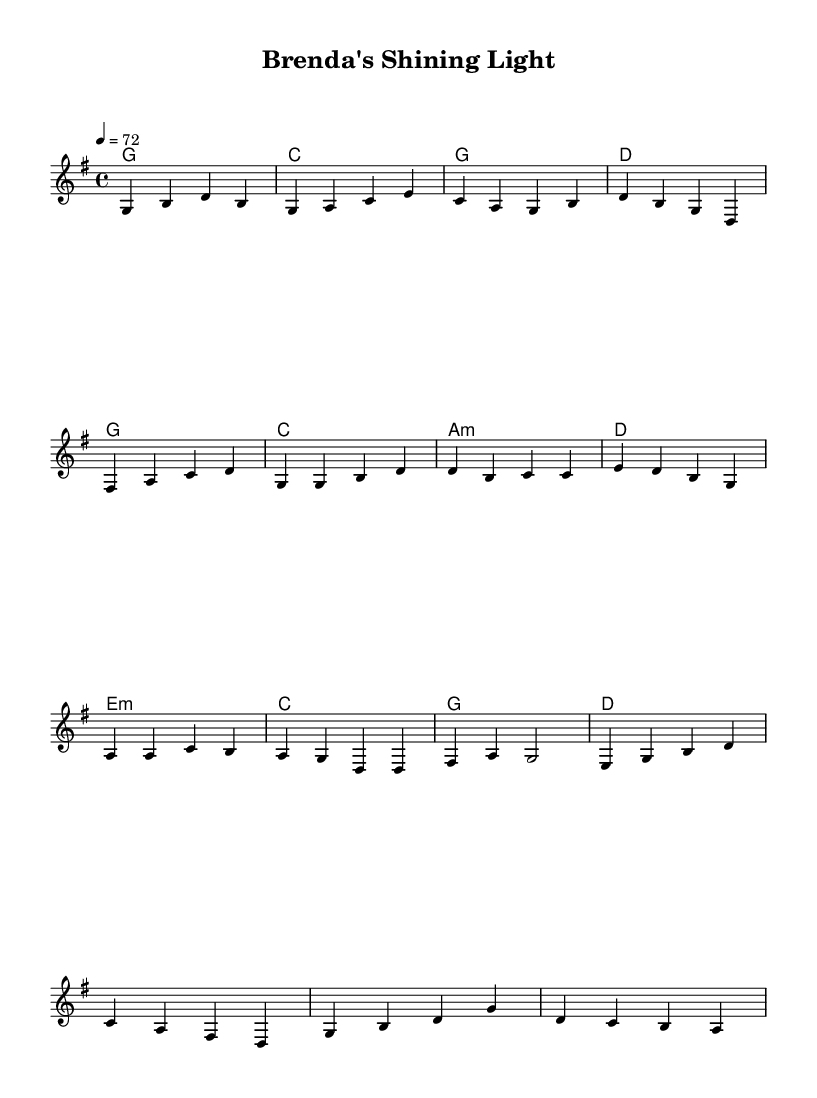What is the key signature of this music? The key signature in the piece is G major, which has one sharp (F#). This can be identified from the key signature indicated at the beginning of the score.
Answer: G major What is the time signature of this music? The time signature given in the score is 4/4, which is indicated right after the key signature at the beginning of the piece. This means there are four beats in each measure.
Answer: 4/4 What is the tempo marking for this piece? The tempo marking is indicated as "4 = 72", meaning there are 72 beats per minute, with each beat represented as a quarter note. This is noted at the beginning section of the score.
Answer: 72 How many measures are there in the verse? The verse consists of four measures as presented in the notated melody section, where each measure is separated by a vertical bar line.
Answer: 4 What is the emotional theme expressed in the lyrics? The lyrics convey a theme of personal growth and resilience, referencing rising up and overcoming struggles. This can be inferred from the phrases in the chorus and bridge lyrics which speak to transformation and triumph over adversity.
Answer: Resilience Which section of the music is characterized by a shift in emotional tone? The bridge section presents a different emotional tone, featuring more reflective lyrics that signify a transition from struggle to a sense of achievement and self-discovery. This can be seen in the lyrics and the chord changes.
Answer: Bridge 